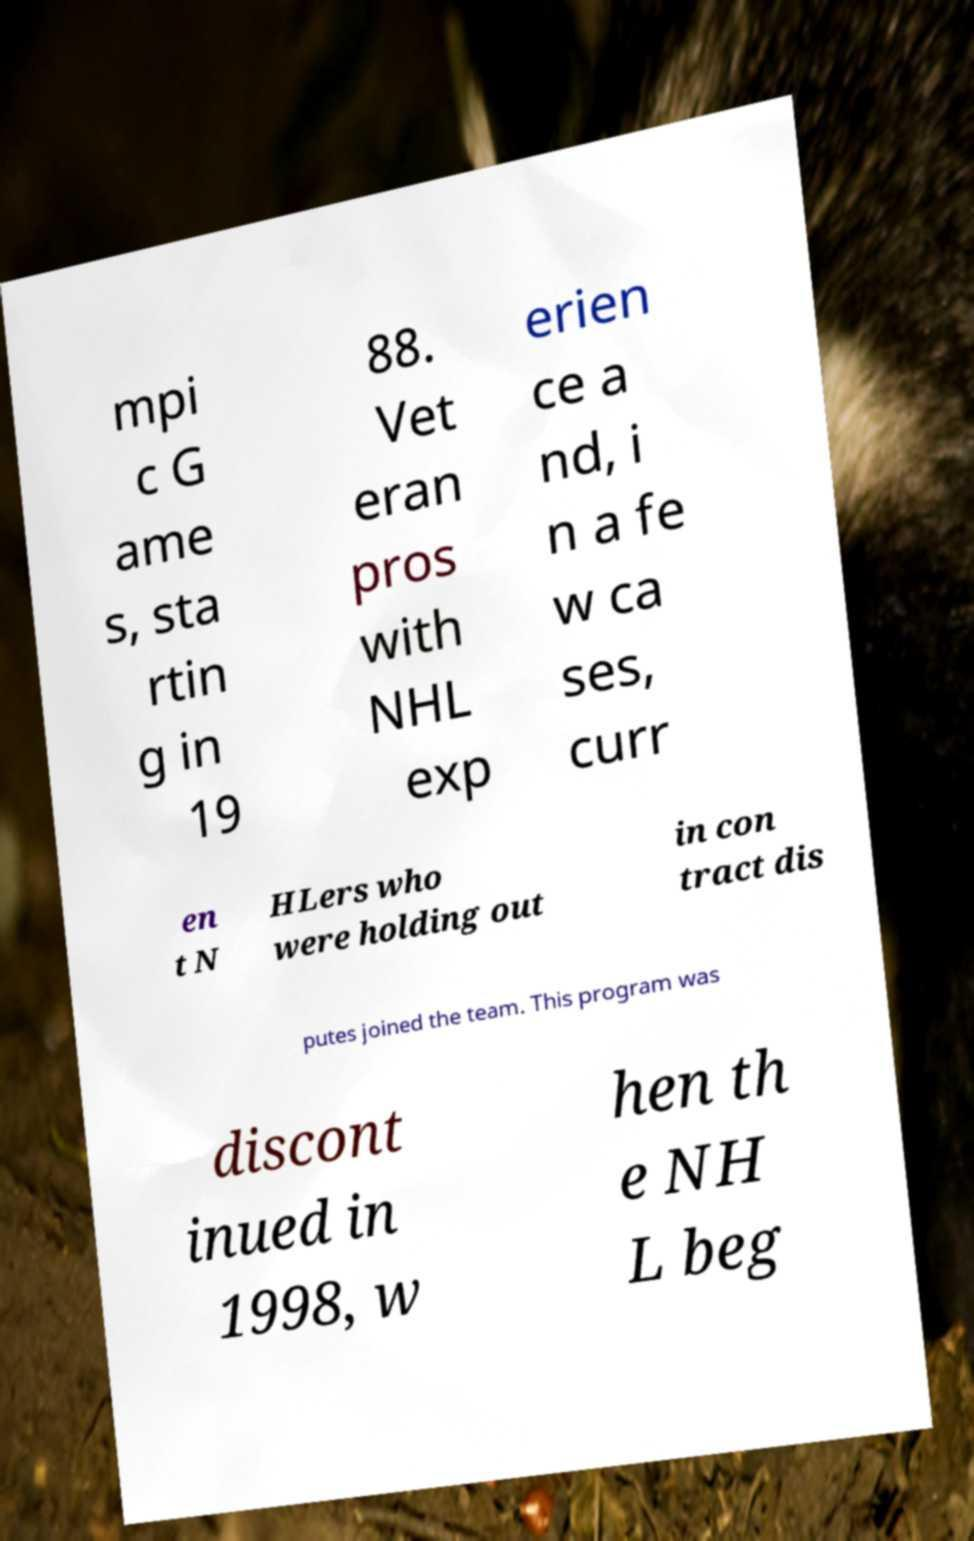I need the written content from this picture converted into text. Can you do that? mpi c G ame s, sta rtin g in 19 88. Vet eran pros with NHL exp erien ce a nd, i n a fe w ca ses, curr en t N HLers who were holding out in con tract dis putes joined the team. This program was discont inued in 1998, w hen th e NH L beg 